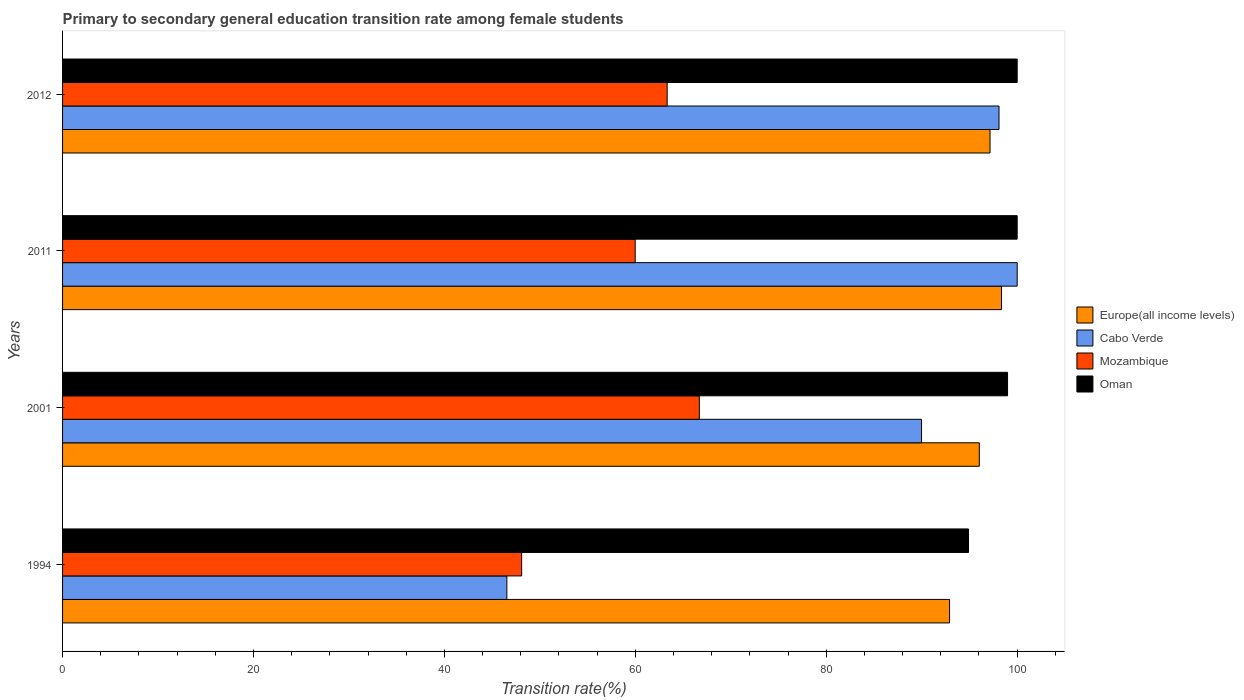How many different coloured bars are there?
Offer a very short reply. 4. How many groups of bars are there?
Give a very brief answer. 4. Are the number of bars on each tick of the Y-axis equal?
Your response must be concise. Yes. What is the label of the 4th group of bars from the top?
Make the answer very short. 1994. What is the transition rate in Mozambique in 2001?
Make the answer very short. 66.7. Across all years, what is the minimum transition rate in Mozambique?
Provide a short and direct response. 48.09. In which year was the transition rate in Oman maximum?
Ensure brevity in your answer.  2011. In which year was the transition rate in Oman minimum?
Give a very brief answer. 1994. What is the total transition rate in Oman in the graph?
Offer a very short reply. 393.89. What is the difference between the transition rate in Cabo Verde in 1994 and that in 2001?
Your answer should be compact. -43.44. What is the difference between the transition rate in Cabo Verde in 2001 and the transition rate in Europe(all income levels) in 2012?
Give a very brief answer. -7.18. What is the average transition rate in Cabo Verde per year?
Make the answer very short. 83.66. In the year 2011, what is the difference between the transition rate in Oman and transition rate in Europe(all income levels)?
Keep it short and to the point. 1.64. In how many years, is the transition rate in Oman greater than 60 %?
Provide a short and direct response. 4. What is the ratio of the transition rate in Mozambique in 2001 to that in 2012?
Provide a succinct answer. 1.05. What is the difference between the highest and the second highest transition rate in Mozambique?
Your answer should be very brief. 3.37. What is the difference between the highest and the lowest transition rate in Europe(all income levels)?
Your answer should be very brief. 5.44. In how many years, is the transition rate in Mozambique greater than the average transition rate in Mozambique taken over all years?
Your answer should be very brief. 3. Is the sum of the transition rate in Mozambique in 1994 and 2001 greater than the maximum transition rate in Europe(all income levels) across all years?
Keep it short and to the point. Yes. Is it the case that in every year, the sum of the transition rate in Europe(all income levels) and transition rate in Cabo Verde is greater than the sum of transition rate in Oman and transition rate in Mozambique?
Provide a succinct answer. No. What does the 1st bar from the top in 2001 represents?
Your response must be concise. Oman. What does the 1st bar from the bottom in 2012 represents?
Keep it short and to the point. Europe(all income levels). Is it the case that in every year, the sum of the transition rate in Europe(all income levels) and transition rate in Oman is greater than the transition rate in Mozambique?
Make the answer very short. Yes. Does the graph contain any zero values?
Your answer should be compact. No. Where does the legend appear in the graph?
Your answer should be very brief. Center right. What is the title of the graph?
Ensure brevity in your answer.  Primary to secondary general education transition rate among female students. Does "Central Europe" appear as one of the legend labels in the graph?
Your answer should be compact. No. What is the label or title of the X-axis?
Provide a short and direct response. Transition rate(%). What is the Transition rate(%) of Europe(all income levels) in 1994?
Your response must be concise. 92.92. What is the Transition rate(%) of Cabo Verde in 1994?
Provide a succinct answer. 46.54. What is the Transition rate(%) of Mozambique in 1994?
Your answer should be very brief. 48.09. What is the Transition rate(%) of Oman in 1994?
Make the answer very short. 94.9. What is the Transition rate(%) in Europe(all income levels) in 2001?
Make the answer very short. 96.03. What is the Transition rate(%) in Cabo Verde in 2001?
Offer a very short reply. 89.98. What is the Transition rate(%) in Mozambique in 2001?
Offer a very short reply. 66.7. What is the Transition rate(%) of Oman in 2001?
Keep it short and to the point. 98.99. What is the Transition rate(%) in Europe(all income levels) in 2011?
Give a very brief answer. 98.36. What is the Transition rate(%) of Mozambique in 2011?
Provide a short and direct response. 59.99. What is the Transition rate(%) of Oman in 2011?
Your response must be concise. 100. What is the Transition rate(%) of Europe(all income levels) in 2012?
Give a very brief answer. 97.16. What is the Transition rate(%) in Cabo Verde in 2012?
Give a very brief answer. 98.1. What is the Transition rate(%) of Mozambique in 2012?
Ensure brevity in your answer.  63.34. Across all years, what is the maximum Transition rate(%) in Europe(all income levels)?
Your answer should be compact. 98.36. Across all years, what is the maximum Transition rate(%) in Cabo Verde?
Your response must be concise. 100. Across all years, what is the maximum Transition rate(%) of Mozambique?
Offer a terse response. 66.7. Across all years, what is the minimum Transition rate(%) of Europe(all income levels)?
Your response must be concise. 92.92. Across all years, what is the minimum Transition rate(%) of Cabo Verde?
Provide a succinct answer. 46.54. Across all years, what is the minimum Transition rate(%) of Mozambique?
Offer a very short reply. 48.09. Across all years, what is the minimum Transition rate(%) of Oman?
Your response must be concise. 94.9. What is the total Transition rate(%) in Europe(all income levels) in the graph?
Provide a short and direct response. 384.47. What is the total Transition rate(%) in Cabo Verde in the graph?
Provide a succinct answer. 334.62. What is the total Transition rate(%) in Mozambique in the graph?
Provide a short and direct response. 238.12. What is the total Transition rate(%) in Oman in the graph?
Make the answer very short. 393.89. What is the difference between the Transition rate(%) of Europe(all income levels) in 1994 and that in 2001?
Provide a succinct answer. -3.12. What is the difference between the Transition rate(%) in Cabo Verde in 1994 and that in 2001?
Your response must be concise. -43.44. What is the difference between the Transition rate(%) of Mozambique in 1994 and that in 2001?
Ensure brevity in your answer.  -18.61. What is the difference between the Transition rate(%) of Oman in 1994 and that in 2001?
Give a very brief answer. -4.09. What is the difference between the Transition rate(%) in Europe(all income levels) in 1994 and that in 2011?
Your answer should be very brief. -5.44. What is the difference between the Transition rate(%) of Cabo Verde in 1994 and that in 2011?
Your answer should be very brief. -53.46. What is the difference between the Transition rate(%) of Mozambique in 1994 and that in 2011?
Make the answer very short. -11.89. What is the difference between the Transition rate(%) in Oman in 1994 and that in 2011?
Provide a succinct answer. -5.1. What is the difference between the Transition rate(%) in Europe(all income levels) in 1994 and that in 2012?
Provide a short and direct response. -4.24. What is the difference between the Transition rate(%) in Cabo Verde in 1994 and that in 2012?
Offer a very short reply. -51.55. What is the difference between the Transition rate(%) in Mozambique in 1994 and that in 2012?
Your response must be concise. -15.24. What is the difference between the Transition rate(%) in Oman in 1994 and that in 2012?
Your response must be concise. -5.1. What is the difference between the Transition rate(%) of Europe(all income levels) in 2001 and that in 2011?
Give a very brief answer. -2.33. What is the difference between the Transition rate(%) in Cabo Verde in 2001 and that in 2011?
Ensure brevity in your answer.  -10.02. What is the difference between the Transition rate(%) of Mozambique in 2001 and that in 2011?
Your answer should be very brief. 6.72. What is the difference between the Transition rate(%) of Oman in 2001 and that in 2011?
Keep it short and to the point. -1.01. What is the difference between the Transition rate(%) of Europe(all income levels) in 2001 and that in 2012?
Give a very brief answer. -1.12. What is the difference between the Transition rate(%) of Cabo Verde in 2001 and that in 2012?
Provide a short and direct response. -8.12. What is the difference between the Transition rate(%) in Mozambique in 2001 and that in 2012?
Keep it short and to the point. 3.37. What is the difference between the Transition rate(%) in Oman in 2001 and that in 2012?
Your response must be concise. -1.01. What is the difference between the Transition rate(%) of Europe(all income levels) in 2011 and that in 2012?
Keep it short and to the point. 1.2. What is the difference between the Transition rate(%) in Cabo Verde in 2011 and that in 2012?
Ensure brevity in your answer.  1.9. What is the difference between the Transition rate(%) in Mozambique in 2011 and that in 2012?
Give a very brief answer. -3.35. What is the difference between the Transition rate(%) of Oman in 2011 and that in 2012?
Offer a terse response. 0. What is the difference between the Transition rate(%) in Europe(all income levels) in 1994 and the Transition rate(%) in Cabo Verde in 2001?
Provide a succinct answer. 2.94. What is the difference between the Transition rate(%) in Europe(all income levels) in 1994 and the Transition rate(%) in Mozambique in 2001?
Keep it short and to the point. 26.21. What is the difference between the Transition rate(%) in Europe(all income levels) in 1994 and the Transition rate(%) in Oman in 2001?
Provide a succinct answer. -6.07. What is the difference between the Transition rate(%) in Cabo Verde in 1994 and the Transition rate(%) in Mozambique in 2001?
Offer a terse response. -20.16. What is the difference between the Transition rate(%) of Cabo Verde in 1994 and the Transition rate(%) of Oman in 2001?
Keep it short and to the point. -52.45. What is the difference between the Transition rate(%) in Mozambique in 1994 and the Transition rate(%) in Oman in 2001?
Your response must be concise. -50.9. What is the difference between the Transition rate(%) in Europe(all income levels) in 1994 and the Transition rate(%) in Cabo Verde in 2011?
Offer a very short reply. -7.08. What is the difference between the Transition rate(%) of Europe(all income levels) in 1994 and the Transition rate(%) of Mozambique in 2011?
Keep it short and to the point. 32.93. What is the difference between the Transition rate(%) of Europe(all income levels) in 1994 and the Transition rate(%) of Oman in 2011?
Provide a succinct answer. -7.08. What is the difference between the Transition rate(%) of Cabo Verde in 1994 and the Transition rate(%) of Mozambique in 2011?
Make the answer very short. -13.44. What is the difference between the Transition rate(%) of Cabo Verde in 1994 and the Transition rate(%) of Oman in 2011?
Your response must be concise. -53.46. What is the difference between the Transition rate(%) of Mozambique in 1994 and the Transition rate(%) of Oman in 2011?
Keep it short and to the point. -51.91. What is the difference between the Transition rate(%) in Europe(all income levels) in 1994 and the Transition rate(%) in Cabo Verde in 2012?
Make the answer very short. -5.18. What is the difference between the Transition rate(%) in Europe(all income levels) in 1994 and the Transition rate(%) in Mozambique in 2012?
Make the answer very short. 29.58. What is the difference between the Transition rate(%) of Europe(all income levels) in 1994 and the Transition rate(%) of Oman in 2012?
Keep it short and to the point. -7.08. What is the difference between the Transition rate(%) in Cabo Verde in 1994 and the Transition rate(%) in Mozambique in 2012?
Make the answer very short. -16.79. What is the difference between the Transition rate(%) in Cabo Verde in 1994 and the Transition rate(%) in Oman in 2012?
Give a very brief answer. -53.46. What is the difference between the Transition rate(%) in Mozambique in 1994 and the Transition rate(%) in Oman in 2012?
Make the answer very short. -51.91. What is the difference between the Transition rate(%) of Europe(all income levels) in 2001 and the Transition rate(%) of Cabo Verde in 2011?
Offer a very short reply. -3.97. What is the difference between the Transition rate(%) in Europe(all income levels) in 2001 and the Transition rate(%) in Mozambique in 2011?
Keep it short and to the point. 36.05. What is the difference between the Transition rate(%) in Europe(all income levels) in 2001 and the Transition rate(%) in Oman in 2011?
Make the answer very short. -3.97. What is the difference between the Transition rate(%) of Cabo Verde in 2001 and the Transition rate(%) of Mozambique in 2011?
Offer a very short reply. 30. What is the difference between the Transition rate(%) in Cabo Verde in 2001 and the Transition rate(%) in Oman in 2011?
Give a very brief answer. -10.02. What is the difference between the Transition rate(%) of Mozambique in 2001 and the Transition rate(%) of Oman in 2011?
Provide a succinct answer. -33.3. What is the difference between the Transition rate(%) in Europe(all income levels) in 2001 and the Transition rate(%) in Cabo Verde in 2012?
Keep it short and to the point. -2.06. What is the difference between the Transition rate(%) in Europe(all income levels) in 2001 and the Transition rate(%) in Mozambique in 2012?
Make the answer very short. 32.7. What is the difference between the Transition rate(%) of Europe(all income levels) in 2001 and the Transition rate(%) of Oman in 2012?
Ensure brevity in your answer.  -3.97. What is the difference between the Transition rate(%) of Cabo Verde in 2001 and the Transition rate(%) of Mozambique in 2012?
Provide a succinct answer. 26.65. What is the difference between the Transition rate(%) of Cabo Verde in 2001 and the Transition rate(%) of Oman in 2012?
Provide a succinct answer. -10.02. What is the difference between the Transition rate(%) in Mozambique in 2001 and the Transition rate(%) in Oman in 2012?
Your answer should be compact. -33.3. What is the difference between the Transition rate(%) of Europe(all income levels) in 2011 and the Transition rate(%) of Cabo Verde in 2012?
Ensure brevity in your answer.  0.26. What is the difference between the Transition rate(%) in Europe(all income levels) in 2011 and the Transition rate(%) in Mozambique in 2012?
Provide a succinct answer. 35.02. What is the difference between the Transition rate(%) of Europe(all income levels) in 2011 and the Transition rate(%) of Oman in 2012?
Your response must be concise. -1.64. What is the difference between the Transition rate(%) of Cabo Verde in 2011 and the Transition rate(%) of Mozambique in 2012?
Your answer should be compact. 36.66. What is the difference between the Transition rate(%) of Mozambique in 2011 and the Transition rate(%) of Oman in 2012?
Your answer should be compact. -40.01. What is the average Transition rate(%) in Europe(all income levels) per year?
Provide a short and direct response. 96.12. What is the average Transition rate(%) in Cabo Verde per year?
Make the answer very short. 83.66. What is the average Transition rate(%) in Mozambique per year?
Your answer should be very brief. 59.53. What is the average Transition rate(%) of Oman per year?
Your response must be concise. 98.47. In the year 1994, what is the difference between the Transition rate(%) of Europe(all income levels) and Transition rate(%) of Cabo Verde?
Provide a short and direct response. 46.38. In the year 1994, what is the difference between the Transition rate(%) of Europe(all income levels) and Transition rate(%) of Mozambique?
Provide a succinct answer. 44.83. In the year 1994, what is the difference between the Transition rate(%) of Europe(all income levels) and Transition rate(%) of Oman?
Your response must be concise. -1.98. In the year 1994, what is the difference between the Transition rate(%) of Cabo Verde and Transition rate(%) of Mozambique?
Provide a short and direct response. -1.55. In the year 1994, what is the difference between the Transition rate(%) in Cabo Verde and Transition rate(%) in Oman?
Offer a very short reply. -48.36. In the year 1994, what is the difference between the Transition rate(%) of Mozambique and Transition rate(%) of Oman?
Offer a terse response. -46.81. In the year 2001, what is the difference between the Transition rate(%) in Europe(all income levels) and Transition rate(%) in Cabo Verde?
Your answer should be very brief. 6.05. In the year 2001, what is the difference between the Transition rate(%) of Europe(all income levels) and Transition rate(%) of Mozambique?
Offer a very short reply. 29.33. In the year 2001, what is the difference between the Transition rate(%) in Europe(all income levels) and Transition rate(%) in Oman?
Provide a succinct answer. -2.96. In the year 2001, what is the difference between the Transition rate(%) of Cabo Verde and Transition rate(%) of Mozambique?
Give a very brief answer. 23.28. In the year 2001, what is the difference between the Transition rate(%) of Cabo Verde and Transition rate(%) of Oman?
Give a very brief answer. -9.01. In the year 2001, what is the difference between the Transition rate(%) of Mozambique and Transition rate(%) of Oman?
Give a very brief answer. -32.29. In the year 2011, what is the difference between the Transition rate(%) in Europe(all income levels) and Transition rate(%) in Cabo Verde?
Make the answer very short. -1.64. In the year 2011, what is the difference between the Transition rate(%) in Europe(all income levels) and Transition rate(%) in Mozambique?
Make the answer very short. 38.37. In the year 2011, what is the difference between the Transition rate(%) in Europe(all income levels) and Transition rate(%) in Oman?
Your answer should be compact. -1.64. In the year 2011, what is the difference between the Transition rate(%) in Cabo Verde and Transition rate(%) in Mozambique?
Give a very brief answer. 40.01. In the year 2011, what is the difference between the Transition rate(%) in Cabo Verde and Transition rate(%) in Oman?
Offer a terse response. 0. In the year 2011, what is the difference between the Transition rate(%) of Mozambique and Transition rate(%) of Oman?
Offer a terse response. -40.01. In the year 2012, what is the difference between the Transition rate(%) of Europe(all income levels) and Transition rate(%) of Cabo Verde?
Your answer should be very brief. -0.94. In the year 2012, what is the difference between the Transition rate(%) in Europe(all income levels) and Transition rate(%) in Mozambique?
Make the answer very short. 33.82. In the year 2012, what is the difference between the Transition rate(%) in Europe(all income levels) and Transition rate(%) in Oman?
Offer a terse response. -2.84. In the year 2012, what is the difference between the Transition rate(%) of Cabo Verde and Transition rate(%) of Mozambique?
Your answer should be compact. 34.76. In the year 2012, what is the difference between the Transition rate(%) in Cabo Verde and Transition rate(%) in Oman?
Ensure brevity in your answer.  -1.9. In the year 2012, what is the difference between the Transition rate(%) of Mozambique and Transition rate(%) of Oman?
Offer a terse response. -36.66. What is the ratio of the Transition rate(%) in Europe(all income levels) in 1994 to that in 2001?
Keep it short and to the point. 0.97. What is the ratio of the Transition rate(%) in Cabo Verde in 1994 to that in 2001?
Give a very brief answer. 0.52. What is the ratio of the Transition rate(%) of Mozambique in 1994 to that in 2001?
Your response must be concise. 0.72. What is the ratio of the Transition rate(%) of Oman in 1994 to that in 2001?
Provide a short and direct response. 0.96. What is the ratio of the Transition rate(%) of Europe(all income levels) in 1994 to that in 2011?
Provide a succinct answer. 0.94. What is the ratio of the Transition rate(%) in Cabo Verde in 1994 to that in 2011?
Your response must be concise. 0.47. What is the ratio of the Transition rate(%) in Mozambique in 1994 to that in 2011?
Provide a succinct answer. 0.8. What is the ratio of the Transition rate(%) of Oman in 1994 to that in 2011?
Keep it short and to the point. 0.95. What is the ratio of the Transition rate(%) of Europe(all income levels) in 1994 to that in 2012?
Your answer should be very brief. 0.96. What is the ratio of the Transition rate(%) in Cabo Verde in 1994 to that in 2012?
Provide a succinct answer. 0.47. What is the ratio of the Transition rate(%) of Mozambique in 1994 to that in 2012?
Offer a very short reply. 0.76. What is the ratio of the Transition rate(%) of Oman in 1994 to that in 2012?
Ensure brevity in your answer.  0.95. What is the ratio of the Transition rate(%) of Europe(all income levels) in 2001 to that in 2011?
Your answer should be very brief. 0.98. What is the ratio of the Transition rate(%) of Cabo Verde in 2001 to that in 2011?
Offer a terse response. 0.9. What is the ratio of the Transition rate(%) of Mozambique in 2001 to that in 2011?
Ensure brevity in your answer.  1.11. What is the ratio of the Transition rate(%) in Europe(all income levels) in 2001 to that in 2012?
Provide a succinct answer. 0.99. What is the ratio of the Transition rate(%) of Cabo Verde in 2001 to that in 2012?
Provide a short and direct response. 0.92. What is the ratio of the Transition rate(%) in Mozambique in 2001 to that in 2012?
Offer a terse response. 1.05. What is the ratio of the Transition rate(%) in Oman in 2001 to that in 2012?
Your response must be concise. 0.99. What is the ratio of the Transition rate(%) of Europe(all income levels) in 2011 to that in 2012?
Your response must be concise. 1.01. What is the ratio of the Transition rate(%) in Cabo Verde in 2011 to that in 2012?
Provide a short and direct response. 1.02. What is the ratio of the Transition rate(%) of Mozambique in 2011 to that in 2012?
Your answer should be compact. 0.95. What is the ratio of the Transition rate(%) of Oman in 2011 to that in 2012?
Keep it short and to the point. 1. What is the difference between the highest and the second highest Transition rate(%) of Europe(all income levels)?
Make the answer very short. 1.2. What is the difference between the highest and the second highest Transition rate(%) in Cabo Verde?
Offer a terse response. 1.9. What is the difference between the highest and the second highest Transition rate(%) in Mozambique?
Offer a very short reply. 3.37. What is the difference between the highest and the lowest Transition rate(%) of Europe(all income levels)?
Your answer should be compact. 5.44. What is the difference between the highest and the lowest Transition rate(%) of Cabo Verde?
Your response must be concise. 53.46. What is the difference between the highest and the lowest Transition rate(%) in Mozambique?
Your response must be concise. 18.61. What is the difference between the highest and the lowest Transition rate(%) in Oman?
Your answer should be very brief. 5.1. 